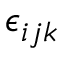<formula> <loc_0><loc_0><loc_500><loc_500>\epsilon _ { i j k }</formula> 